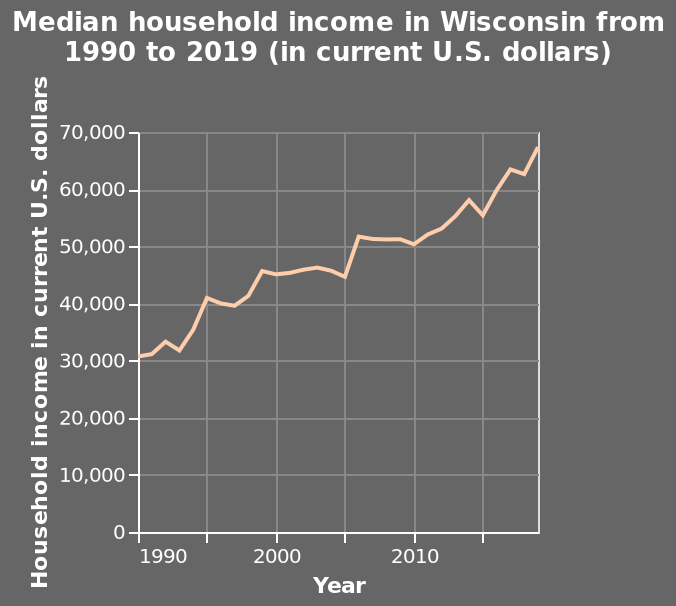<image>
What is the type of scale used for the x-axis?  The x-axis uses a linear scale to plot the years. What is the minimum value for household income on the y-axis? The minimum value for household income on the y-axis is 0 U.S. dollars. Is the maximum value for household income on the y-axis 0 U.S. dollars? No.The minimum value for household income on the y-axis is 0 U.S. dollars. 